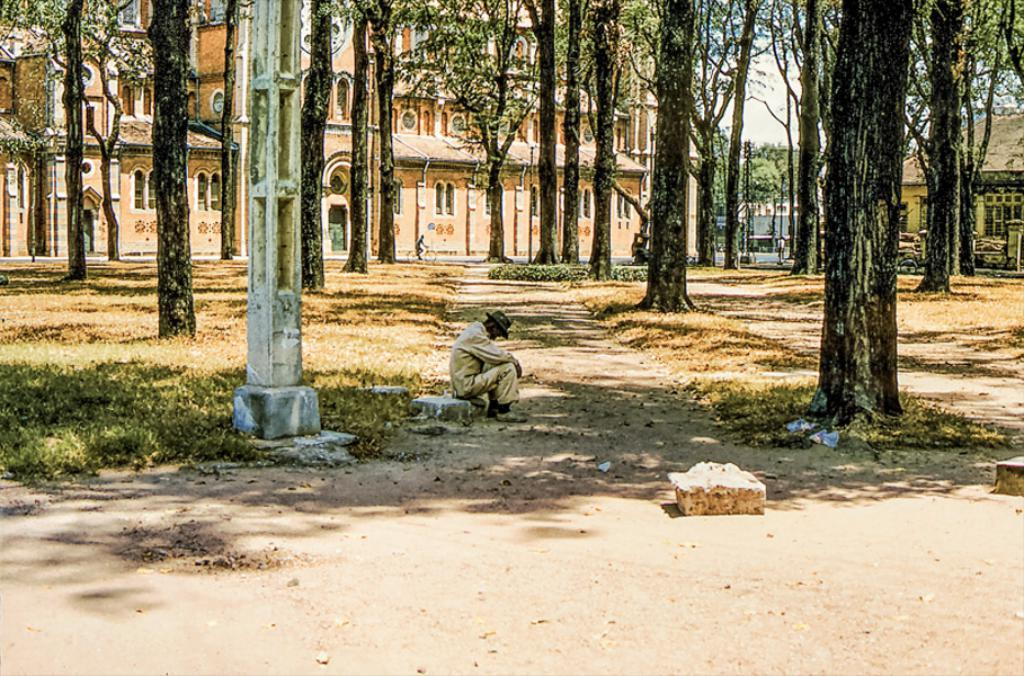What is the man in the image doing? The man is sitting on a stone in the image. What is the man wearing on his head? The man is wearing a hat. What type of vegetation can be seen in the image? There are trees in the image. What structure is visible in the background of the image? There is a house in the background of the image. What type of foot is the man using to climb the stone in the image? The man is sitting on the stone, not climbing it, and there is no mention of a foot or climbing in the image. 